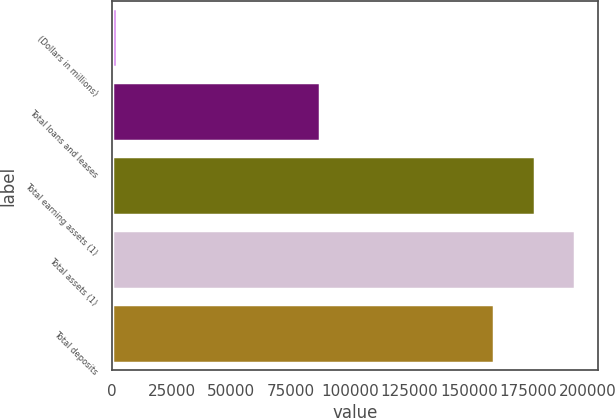Convert chart to OTSL. <chart><loc_0><loc_0><loc_500><loc_500><bar_chart><fcel>(Dollars in millions)<fcel>Total loans and leases<fcel>Total earning assets (1)<fcel>Total assets (1)<fcel>Total deposits<nl><fcel>2008<fcel>87593<fcel>177598<fcel>194495<fcel>160702<nl></chart> 